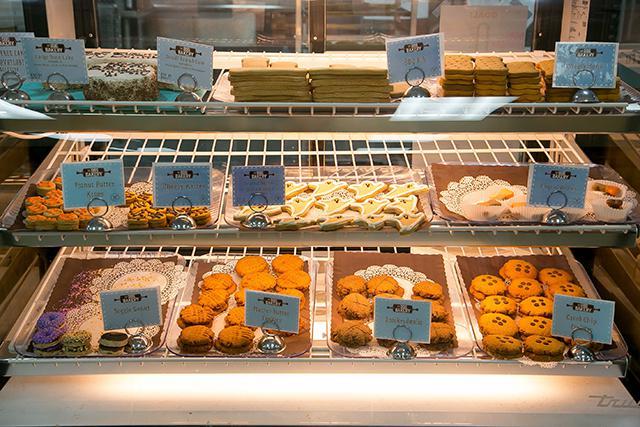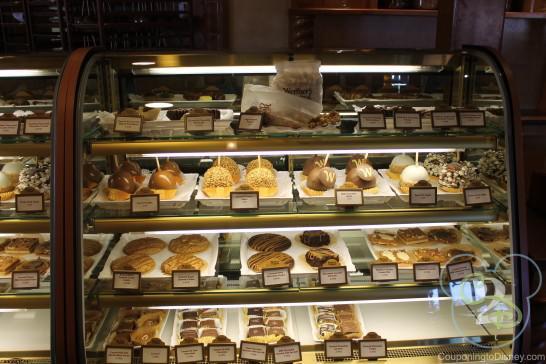The first image is the image on the left, the second image is the image on the right. For the images displayed, is the sentence "The right image shows a glass display case containing white trays of glazed and coated ball-shaped treats with stick handles." factually correct? Answer yes or no. Yes. The first image is the image on the left, the second image is the image on the right. Given the left and right images, does the statement "One of the cases has four shelves displaying different baked goods." hold true? Answer yes or no. Yes. 